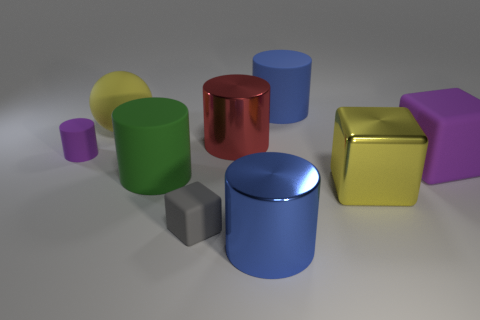Are there any yellow blocks on the right side of the yellow metal object?
Make the answer very short. No. What shape is the blue metal object that is the same size as the red shiny thing?
Your answer should be very brief. Cylinder. Are the purple cube and the green cylinder made of the same material?
Offer a very short reply. Yes. What number of shiny objects are either large cyan cylinders or tiny cylinders?
Make the answer very short. 0. The large rubber object that is the same color as the tiny cylinder is what shape?
Give a very brief answer. Cube. Do the metal cylinder in front of the small purple cylinder and the ball have the same color?
Offer a terse response. No. The yellow object that is in front of the big red cylinder behind the tiny gray matte object is what shape?
Ensure brevity in your answer.  Cube. What number of things are either blocks that are behind the large green cylinder or big cylinders that are right of the gray object?
Your response must be concise. 4. What shape is the other small object that is made of the same material as the gray thing?
Your response must be concise. Cylinder. Are there any other things that are the same color as the big matte ball?
Offer a terse response. Yes. 